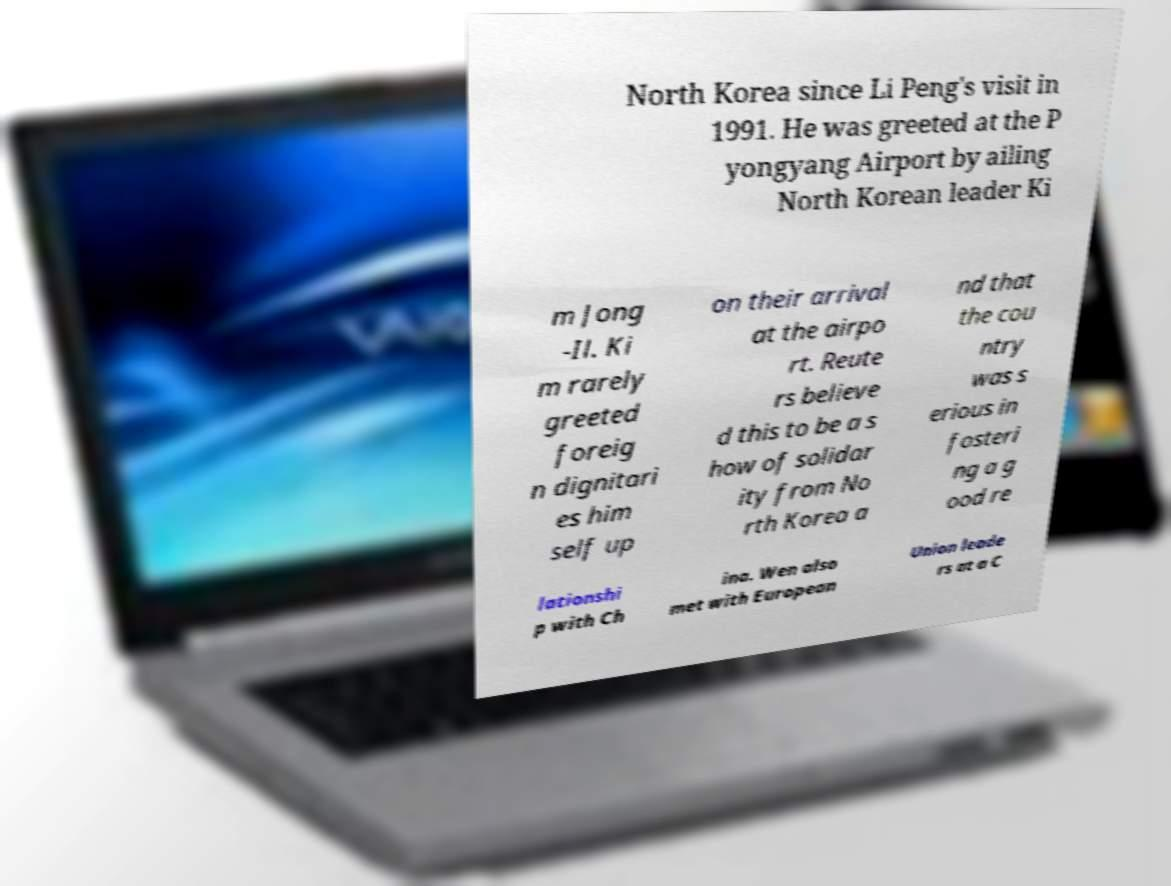What messages or text are displayed in this image? I need them in a readable, typed format. North Korea since Li Peng's visit in 1991. He was greeted at the P yongyang Airport by ailing North Korean leader Ki m Jong -Il. Ki m rarely greeted foreig n dignitari es him self up on their arrival at the airpo rt. Reute rs believe d this to be a s how of solidar ity from No rth Korea a nd that the cou ntry was s erious in fosteri ng a g ood re lationshi p with Ch ina. Wen also met with European Union leade rs at a C 